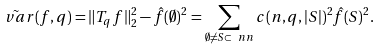<formula> <loc_0><loc_0><loc_500><loc_500>\tilde { \ v a r } ( f , q ) = \| T _ { q } f \| _ { 2 } ^ { 2 } - \hat { f } ( \emptyset ) ^ { 2 } = \sum _ { \emptyset \neq S \subset \ n n } c ( n , q , | S | ) ^ { 2 } \hat { f } ( S ) ^ { 2 } .</formula> 